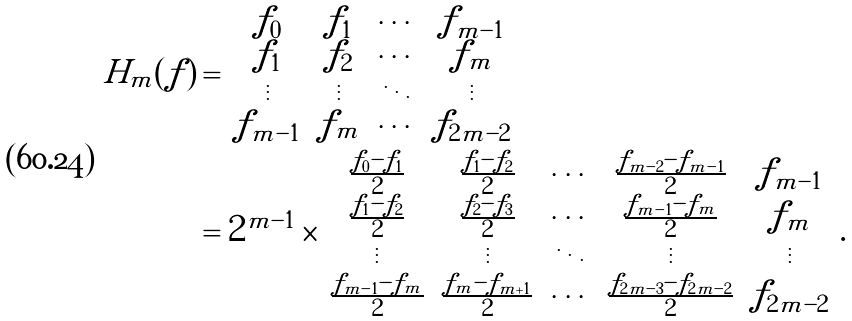<formula> <loc_0><loc_0><loc_500><loc_500>H _ { m } ( f ) & = \left | \begin{matrix} f _ { 0 } & f _ { 1 } & \cdots & f _ { m - 1 } \\ f _ { 1 } & f _ { 2 } & \cdots & f _ { m } \\ \vdots & \vdots & \ddots & \vdots \\ f _ { m - 1 } & f _ { m } & \cdots & f _ { 2 m - 2 } \end{matrix} \right | \\ & = 2 ^ { m - 1 } \times \left | \begin{matrix} \frac { f _ { 0 } - f _ { 1 } } { 2 } & \frac { f _ { 1 } - f _ { 2 } } { 2 } & \cdots & \frac { f _ { m - 2 } - f _ { m - 1 } } { 2 } & f _ { m - 1 } \\ \frac { f _ { 1 } - f _ { 2 } } { 2 } & \frac { f _ { 2 } - f _ { 3 } } { 2 } & \cdots & \frac { f _ { m - 1 } - f _ { m } } { 2 } & f _ { m } \\ \vdots & \vdots & \ddots & \vdots & \vdots \\ \frac { f _ { m - 1 } - f _ { m } } { 2 } & \frac { f _ { m } - f _ { m + 1 } } { 2 } & \cdots & \frac { f _ { 2 m - 3 } - f _ { 2 m - 2 } } { 2 } & f _ { 2 m - 2 } \end{matrix} \right | .</formula> 